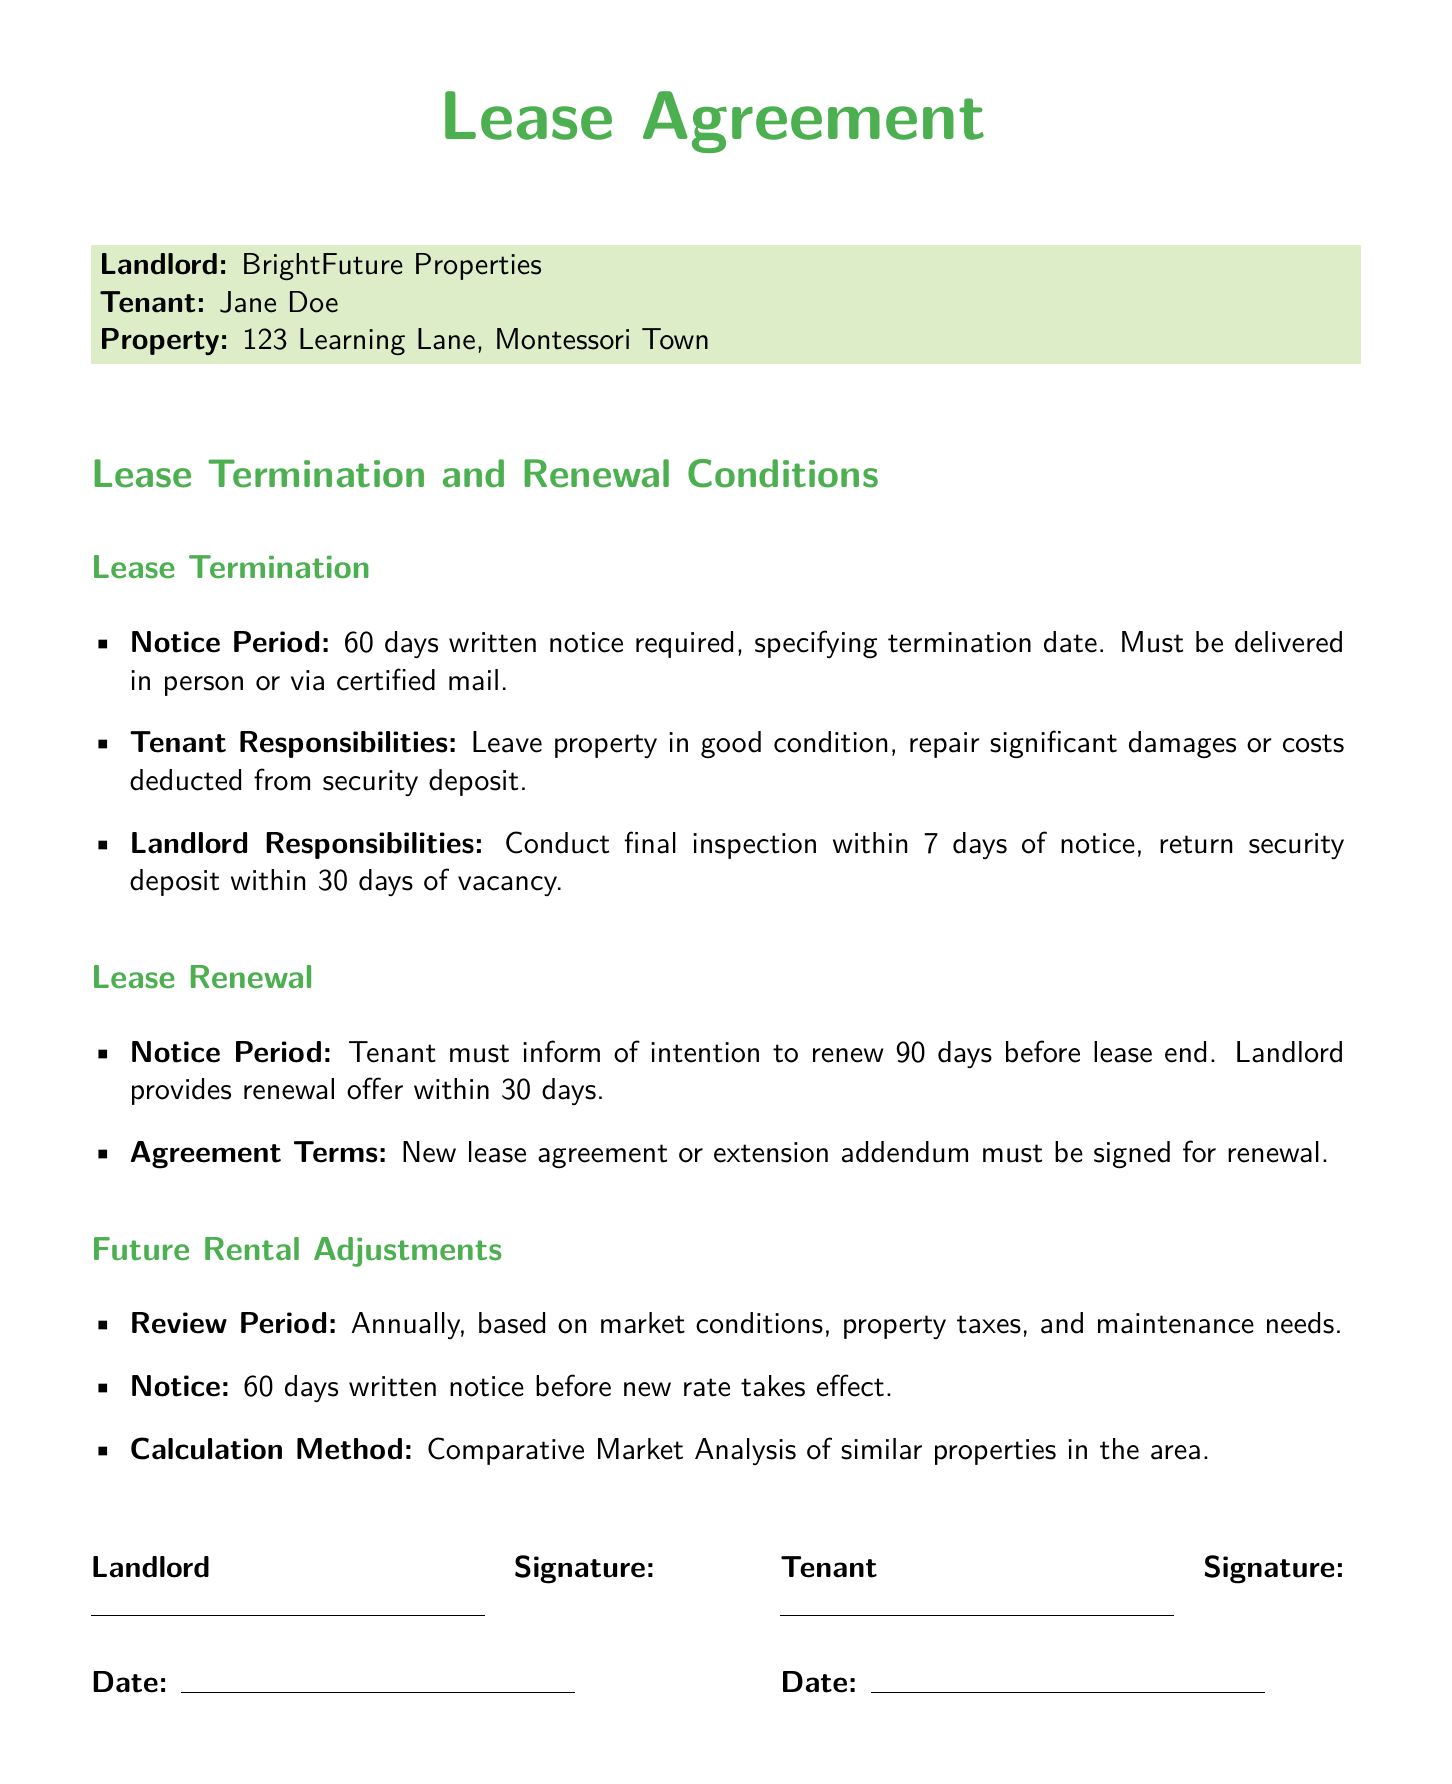What is the required notice period for lease termination? The lease agreement specifies a notice period of 60 days written notice required for lease termination.
Answer: 60 days Who is responsible for repairing significant damages? According to the lease, the tenant is responsible for repairing significant damages or costs deducted from the security deposit.
Answer: Tenant How long does the landlord have to return the security deposit? The document states that the landlord must return the security deposit within 30 days of vacancy.
Answer: 30 days What is the tenant's notice period for lease renewal? The tenant must inform of their intention to renew the lease 90 days before the lease end.
Answer: 90 days How soon must the landlord provide a renewal offer? The landlord is required to provide a renewal offer within 30 days of receiving the tenant's intention to renew.
Answer: 30 days What is the review period for future rental adjustments? The lease agreement indicates that future rental adjustments will be reviewed annually.
Answer: Annually What analysis method is used for calculating rental adjustments? The rental adjustment calculation method is based on a Comparative Market Analysis of similar properties.
Answer: Comparative Market Analysis What is the timeframe for notice before a new rental rate takes effect? The document specifies that a 60 days written notice before the new rate takes effect is required.
Answer: 60 days What must be signed for lease renewal? A new lease agreement or extension addendum must be signed for renewal as per the lease terms.
Answer: New lease agreement or extension addendum 